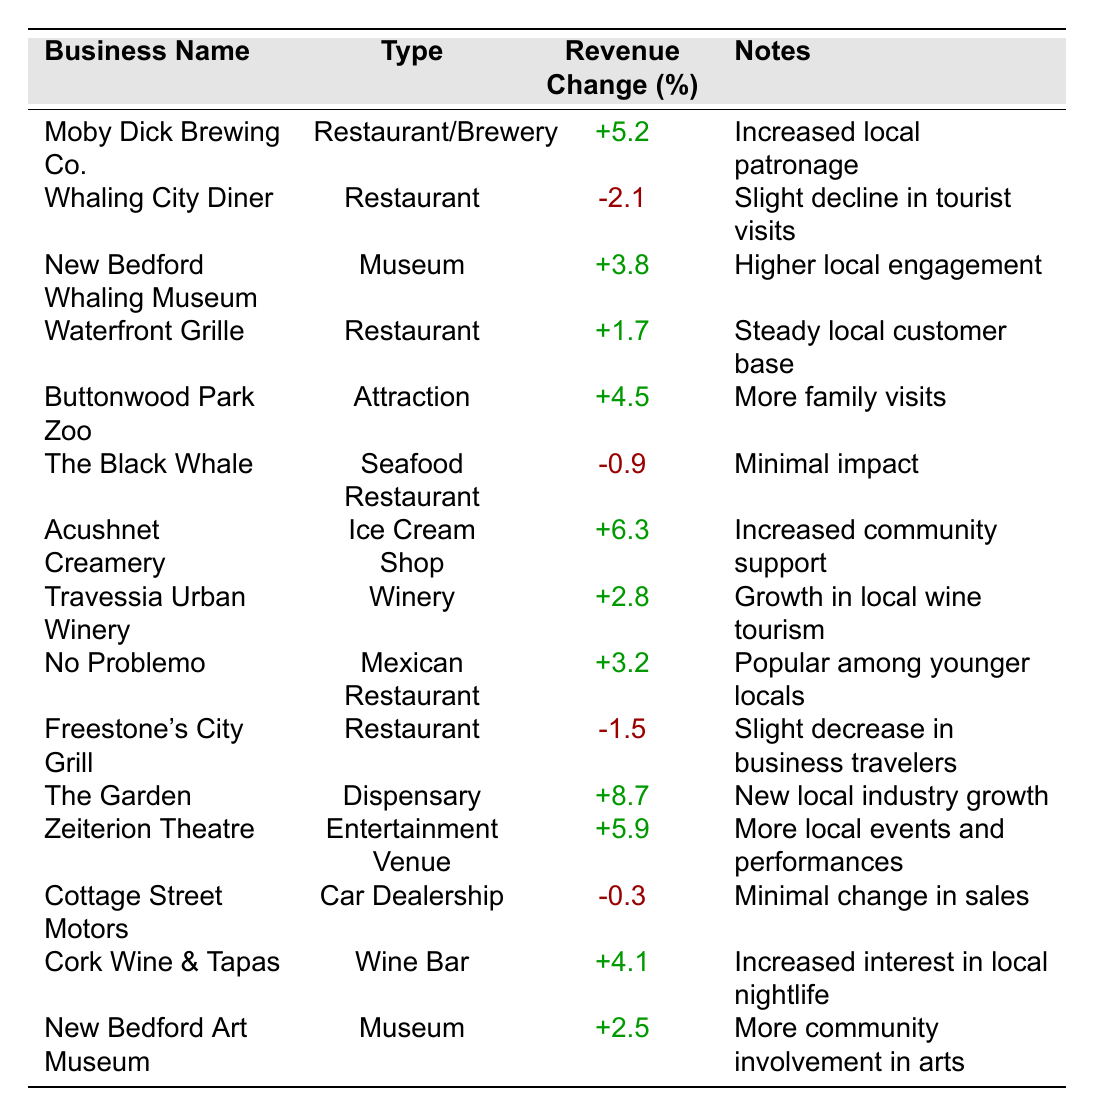What business experienced the highest revenue change? The table provides the revenue changes for each business. The highest percentage listed is +8.7% for The Garden.
Answer: The Garden Which type of business saw a decline in revenue? The table shows negative revenue changes for Whaling City Diner (-2.1%), The Black Whale (-0.9%), and Freestone's City Grill (-1.5%), indicating they faced declines.
Answer: Restaurant What is the average revenue change for all businesses listed? To find the average, add all revenue changes: (5.2 - 2.1 + 3.8 + 1.7 + 4.5 - 0.9 + 6.3 + 2.8 + 3.2 - 1.5 + 8.7 + 5.9 - 0.3 + 4.1 + 2.5) = 38.1. There are 15 businesses, so the average is 38.1 / 15 = 2.54.
Answer: 2.54 Which business had the highest revenue increase percentage? The Garden has the highest revenue change at 8.7%, which is the largest figure in the increase column.
Answer: The Garden Did any ice cream shop experience a revenue increase? Acushnet Creamery, the only ice cream shop listed, had a revenue change of +6.3%, indicating an increase.
Answer: Yes What are the revenue changes for attractions? From the table, Buttonwood Park Zoo showed a +4.5% change, the only attraction listed, indicating an increase.
Answer: +4.5% How many businesses experienced negative revenue changes? By counting the businesses with negative percentages, we find three: Whaling City Diner, The Black Whale, and Freestone's City Grill.
Answer: Three What is the total revenue change for all restaurants combined? Adding the revenue changes for the restaurants: Moby Dick Brewing Co. (5.2) + Whaling City Diner (-2.1) + Waterfront Grille (1.7) + The Black Whale (-0.9) + Freestone's City Grill (-1.5) + No Problemo (3.2) = 5.2 - 2.1 + 1.7 - 0.9 - 1.5 + 3.2 = 5.6% total revenue change.
Answer: 5.6% Which business type had the largest number of positive revenue changes? By reviewing the data, we find there are more positive changes among restaurants, such as Moby Dick Brewing Co., Waterfront Grille, No Problemo, and Cork Wine & Tapas compared to others.
Answer: Restaurant Is the revenue change for the New Bedford Art Museum positive or negative? The New Bedford Art Museum shows a revenue change of +2.5%, which is a positive change indicating growth.
Answer: Positive 